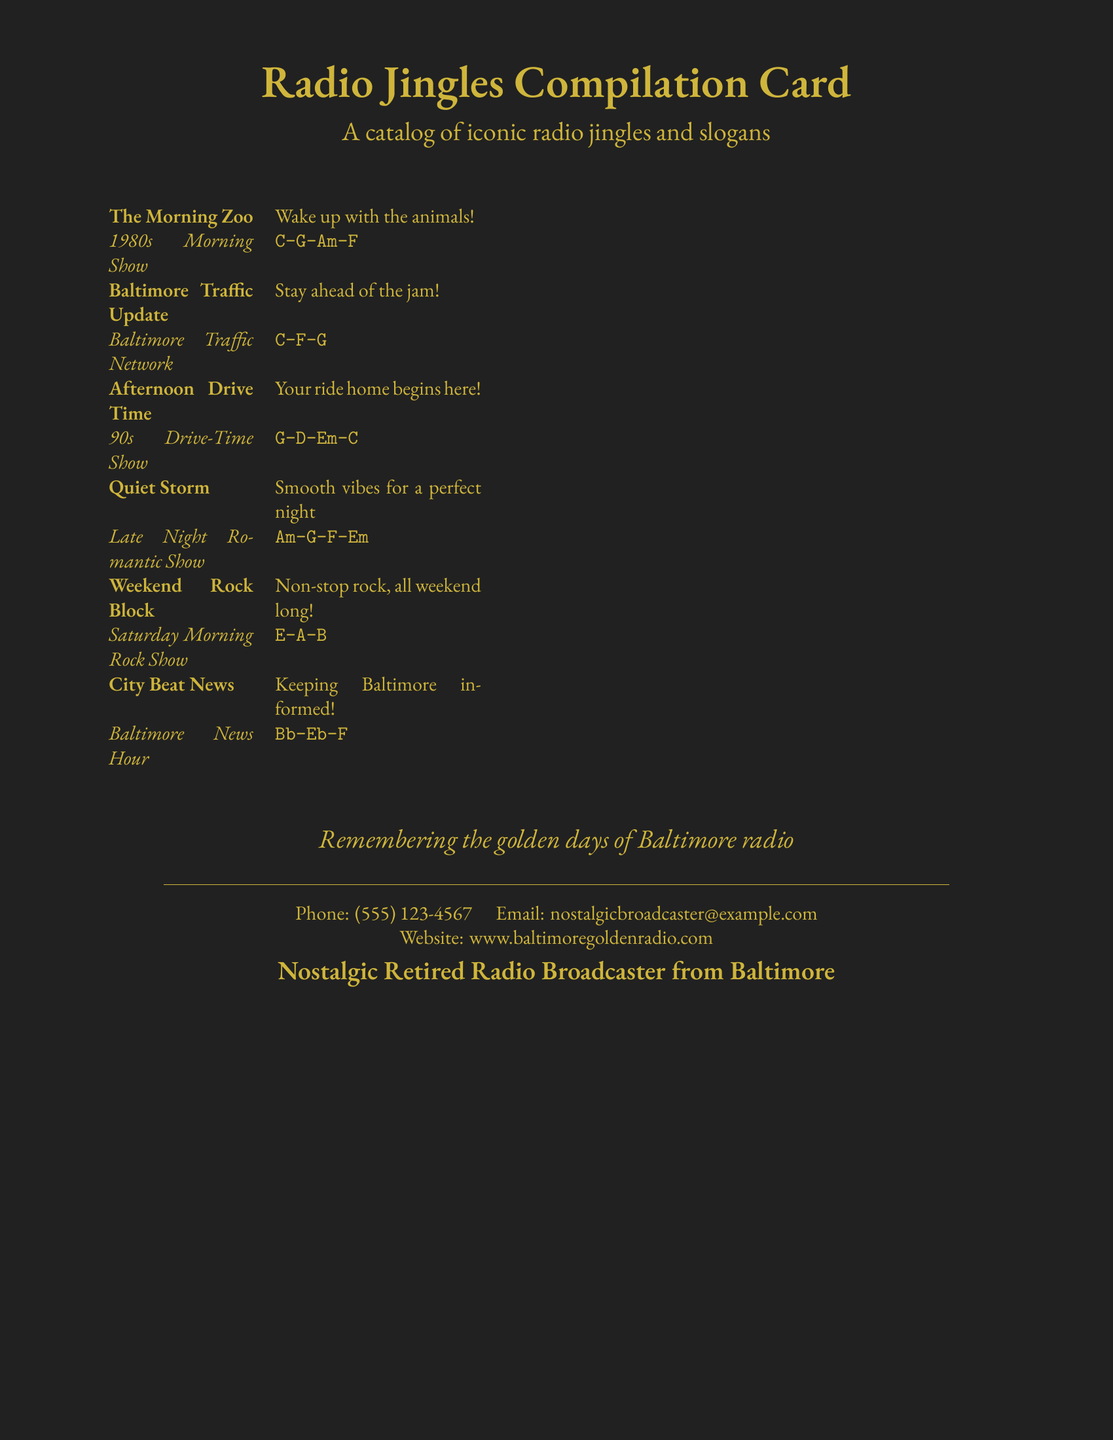What is the title of the document? The title is prominently displayed at the top of the document, introducing its focus.
Answer: Radio Jingles Compilation Card How many jingles are listed in the compilation? By counting the entries in the table, we can determine the total number of jingles featured.
Answer: 6 What is the slogan for "The Morning Zoo"? The slogan appears right next to the jingle title, providing its catchy phrase.
Answer: Wake up with the animals! What year was the "Afternoon Drive Time" jingle from? The year can be inferred from the associated show description mentioned in the document.
Answer: 90s Which jingle corresponds to the Baltimore Traffic Update? The jingle title specifically identifies the catchy phrase related to traffic updates.
Answer: Stay ahead of the jam! What musical chords are associated with the "Quiet Storm"? The musical chords are listed right next to the jingle information in the document.
Answer: Am-G-F-Em What is the phone number provided on the card? The phone number is clearly stated at the bottom of the document for contact purposes.
Answer: (555) 123-4567 What type of content is this document showcasing? The content type can be categorized based on its overall focus and presentation.
Answer: Radio jingles and slogans Who is the intended contact for inquiries on this card? The bottom section indicates the individual associated with the contact information.
Answer: Nostalgic Retired Radio Broadcaster from Baltimore 